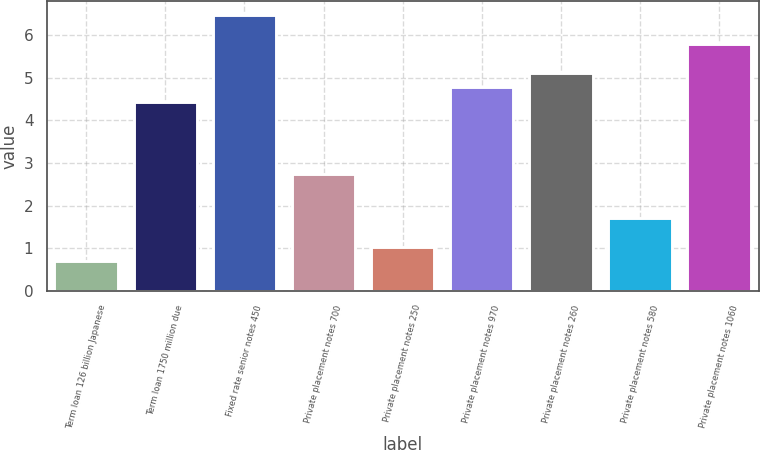<chart> <loc_0><loc_0><loc_500><loc_500><bar_chart><fcel>Term loan 126 billion Japanese<fcel>Term loan 1750 million due<fcel>Fixed rate senior notes 450<fcel>Private placement notes 700<fcel>Private placement notes 250<fcel>Private placement notes 970<fcel>Private placement notes 260<fcel>Private placement notes 580<fcel>Private placement notes 1060<nl><fcel>0.7<fcel>4.44<fcel>6.48<fcel>2.74<fcel>1.04<fcel>4.78<fcel>5.12<fcel>1.72<fcel>5.8<nl></chart> 